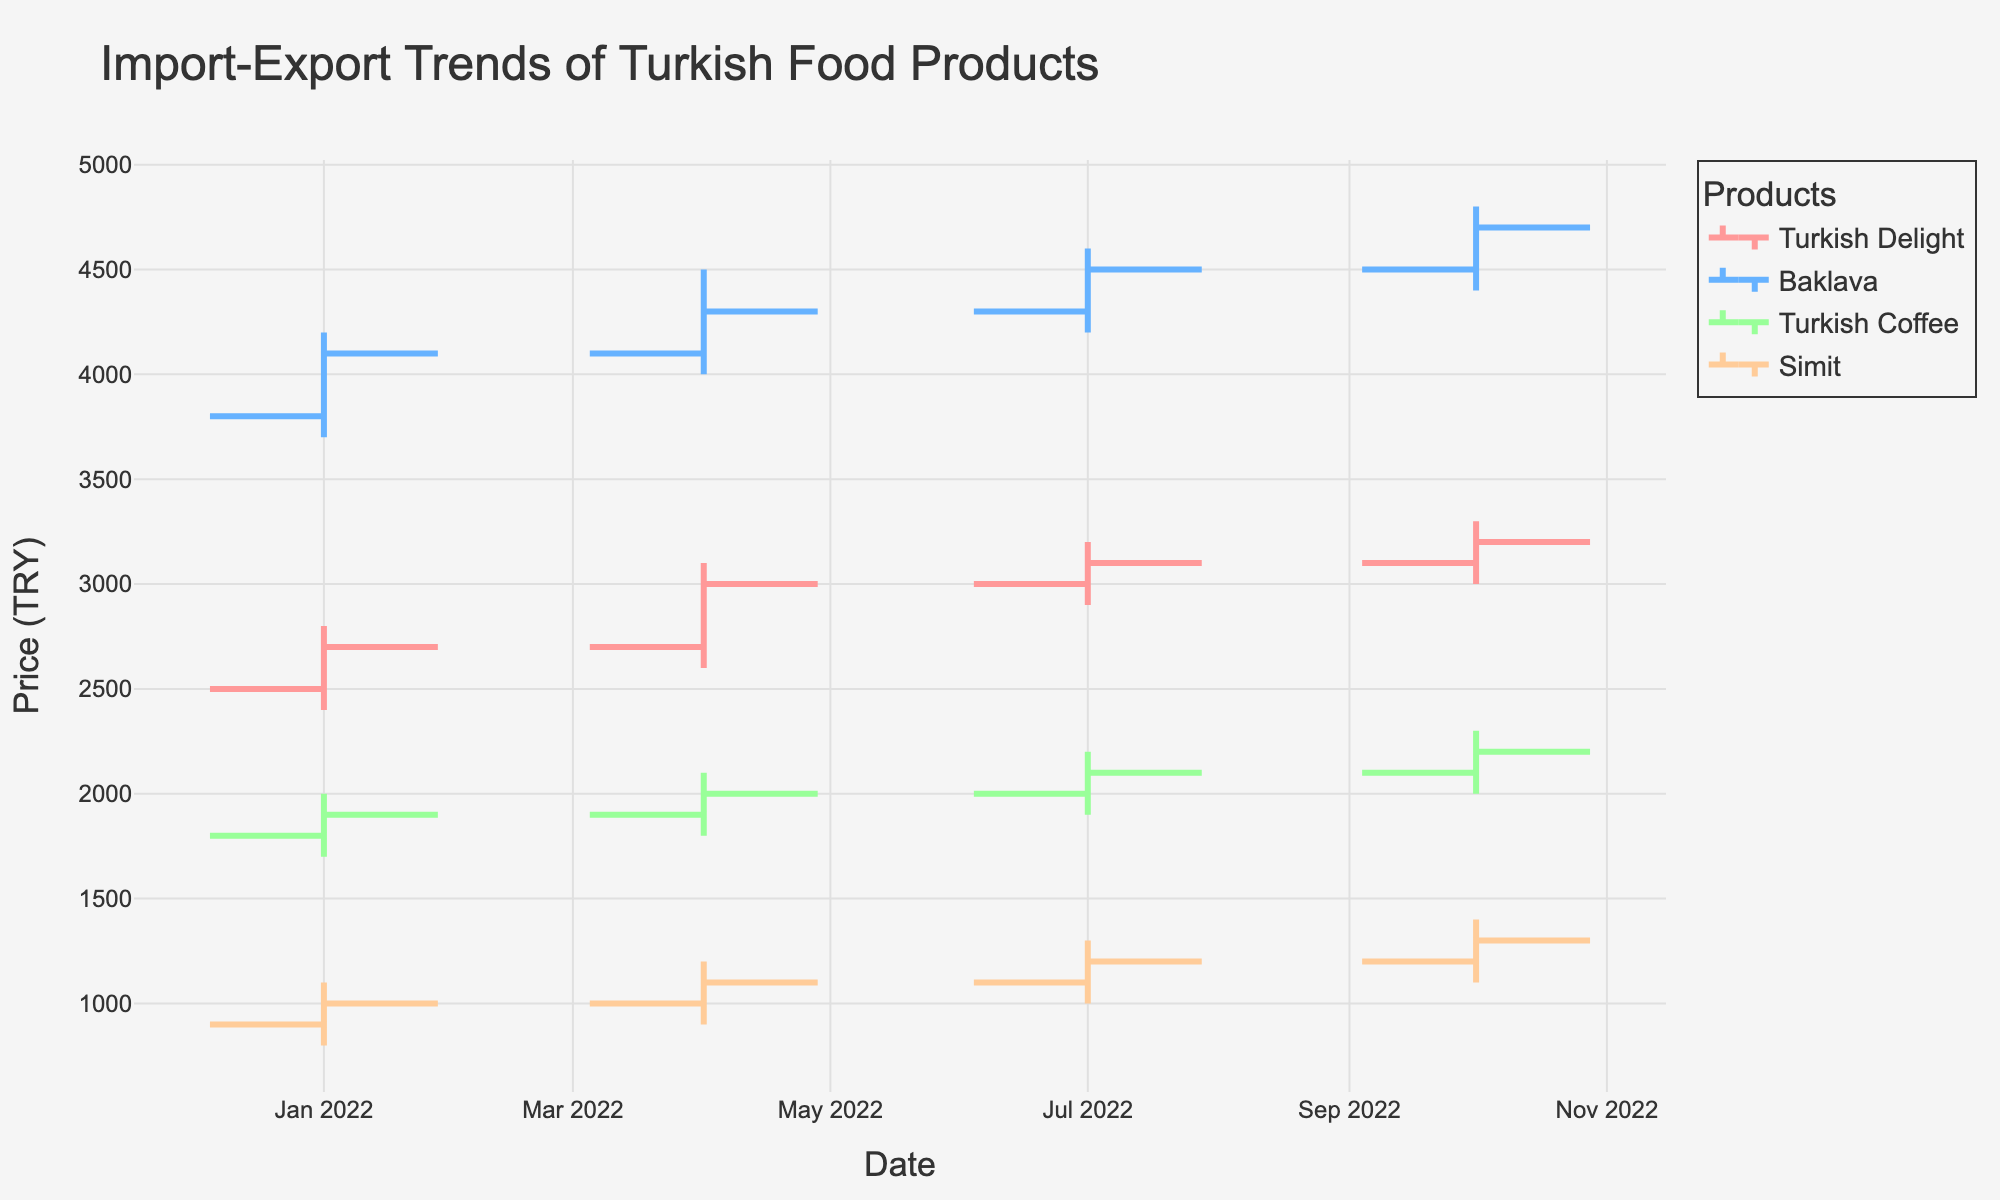What's the title of the plot? The title of the plot is usually positioned at the top center of a graph, with larger font size for easy visibility. Here, the title reads "Import-Export Trends of Turkish Food Products."
Answer: Import-Export Trends of Turkish Food Products What is the color used for Turkish Delight data in the chart? The chart uses specific colors for each product. The color for Turkish Delight data is a shade of red.
Answer: Red Which product has the highest closing price in October 2022? To find this, look at the closing prices for each product in the quarter ending October 2022. Among the listed products (Turkish Delight, Baklava, Turkish Coffee, Simit), Baklava has the highest closing price.
Answer: Baklava What is the trend in the prices of Turkish Coffee from January 2022 to October 2022? Examine the OHLC data points for Turkish Coffee across the given dates. The trend shows a steady increase in prices, with the closing price going from 1900 TRY in January to 2200 TRY in October.
Answer: Increasing How does the opening price of Simit in October 2022 compare to its opening price in January 2022? Compare the opening prices for Simit in January and October 2022. The opening price in January is 900 TRY, and in October it is 1200 TRY. So, the opening price increased by 300 TRY.
Answer: Increased by 300 TRY Which product showed the most significant increase in the high price from April 2022 to July 2022? Check the high prices for each product in both April and July 2022. Turkish Delight increased from 3100 to 3200, Baklava from 4500 to 4600, Turkish Coffee from 2100 to 2200, and Simit from 1200 to 1300. The most significant increase in high price is for Baklava (100 TRY).
Answer: Baklava What is the average closing price of Baklava for the four quarters of 2022? Sum up the closing prices of Baklava for all four quarters (4100, 4300, 4500, 4700) and then divide by 4. The calculation is (4100 + 4300 + 4500 + 4700) / 4 = 4400 TRY.
Answer: 4400 TRY Compare the lowest prices of Turkish Delight and Simit in April 2022. Which one is lower? Look at the OHLC data for April 2022. The low price for Turkish Delight is 2600 TRY, and for Simit, it is 900 TRY. Therefore, Simit has a lower price.
Answer: Simit What is the percentage increase in the closing price of Turkish Delight from January 2022 to October 2022? Find the closing prices for Turkish Delight in January (2700 TRY) and October (3200 TRY). The percentage increase is calculated as ((3200 - 2700) / 2700) * 100 = 18.52%.
Answer: 18.52% 